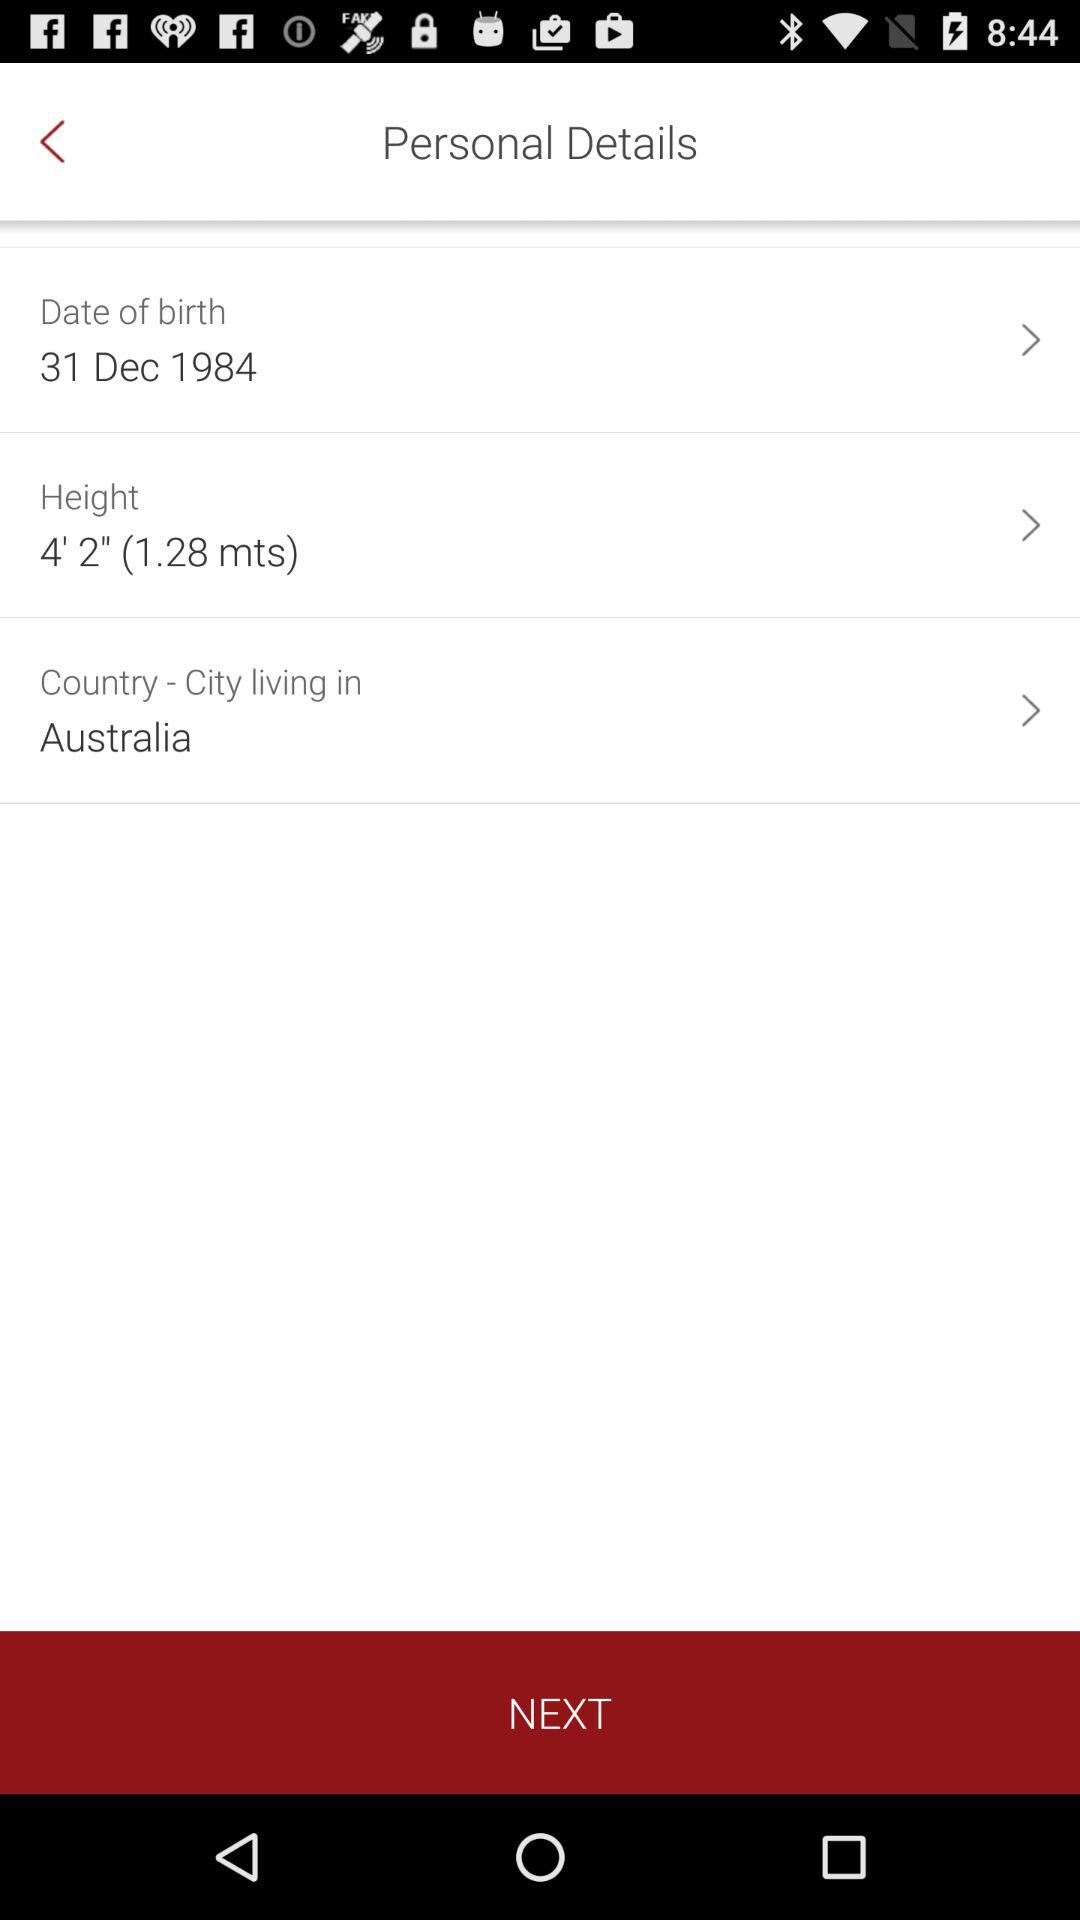How many personal details are there?
Answer the question using a single word or phrase. 3 